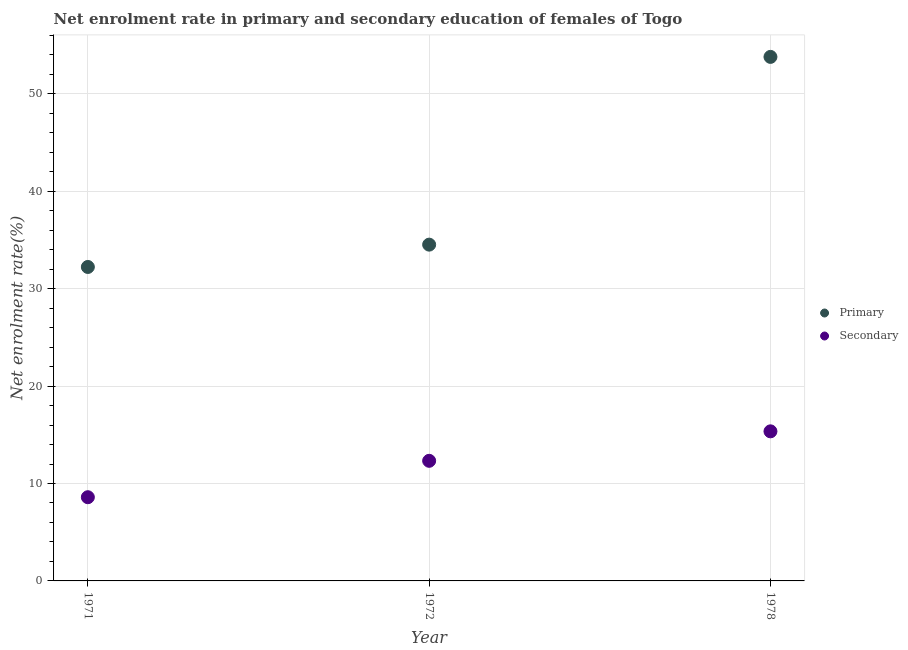Is the number of dotlines equal to the number of legend labels?
Offer a terse response. Yes. What is the enrollment rate in primary education in 1978?
Keep it short and to the point. 53.8. Across all years, what is the maximum enrollment rate in primary education?
Offer a terse response. 53.8. Across all years, what is the minimum enrollment rate in primary education?
Offer a terse response. 32.23. In which year was the enrollment rate in secondary education maximum?
Your response must be concise. 1978. What is the total enrollment rate in primary education in the graph?
Ensure brevity in your answer.  120.55. What is the difference between the enrollment rate in primary education in 1971 and that in 1978?
Keep it short and to the point. -21.57. What is the difference between the enrollment rate in secondary education in 1972 and the enrollment rate in primary education in 1978?
Provide a succinct answer. -41.47. What is the average enrollment rate in secondary education per year?
Your response must be concise. 12.09. In the year 1972, what is the difference between the enrollment rate in secondary education and enrollment rate in primary education?
Ensure brevity in your answer.  -22.19. In how many years, is the enrollment rate in primary education greater than 4 %?
Give a very brief answer. 3. What is the ratio of the enrollment rate in primary education in 1972 to that in 1978?
Your answer should be very brief. 0.64. Is the enrollment rate in secondary education in 1971 less than that in 1972?
Your response must be concise. Yes. Is the difference between the enrollment rate in secondary education in 1972 and 1978 greater than the difference between the enrollment rate in primary education in 1972 and 1978?
Offer a terse response. Yes. What is the difference between the highest and the second highest enrollment rate in primary education?
Offer a very short reply. 19.27. What is the difference between the highest and the lowest enrollment rate in primary education?
Your answer should be compact. 21.57. In how many years, is the enrollment rate in primary education greater than the average enrollment rate in primary education taken over all years?
Ensure brevity in your answer.  1. Does the enrollment rate in primary education monotonically increase over the years?
Your answer should be very brief. Yes. How many dotlines are there?
Offer a terse response. 2. How many years are there in the graph?
Provide a short and direct response. 3. What is the difference between two consecutive major ticks on the Y-axis?
Provide a short and direct response. 10. Are the values on the major ticks of Y-axis written in scientific E-notation?
Make the answer very short. No. Where does the legend appear in the graph?
Your answer should be compact. Center right. What is the title of the graph?
Provide a succinct answer. Net enrolment rate in primary and secondary education of females of Togo. What is the label or title of the Y-axis?
Provide a succinct answer. Net enrolment rate(%). What is the Net enrolment rate(%) of Primary in 1971?
Your answer should be compact. 32.23. What is the Net enrolment rate(%) of Secondary in 1971?
Provide a short and direct response. 8.59. What is the Net enrolment rate(%) of Primary in 1972?
Provide a succinct answer. 34.52. What is the Net enrolment rate(%) in Secondary in 1972?
Offer a terse response. 12.33. What is the Net enrolment rate(%) of Primary in 1978?
Make the answer very short. 53.8. What is the Net enrolment rate(%) in Secondary in 1978?
Provide a short and direct response. 15.36. Across all years, what is the maximum Net enrolment rate(%) of Primary?
Your response must be concise. 53.8. Across all years, what is the maximum Net enrolment rate(%) in Secondary?
Provide a short and direct response. 15.36. Across all years, what is the minimum Net enrolment rate(%) of Primary?
Provide a succinct answer. 32.23. Across all years, what is the minimum Net enrolment rate(%) of Secondary?
Your response must be concise. 8.59. What is the total Net enrolment rate(%) of Primary in the graph?
Offer a very short reply. 120.55. What is the total Net enrolment rate(%) of Secondary in the graph?
Give a very brief answer. 36.28. What is the difference between the Net enrolment rate(%) of Primary in 1971 and that in 1972?
Give a very brief answer. -2.29. What is the difference between the Net enrolment rate(%) of Secondary in 1971 and that in 1972?
Your answer should be very brief. -3.74. What is the difference between the Net enrolment rate(%) of Primary in 1971 and that in 1978?
Make the answer very short. -21.57. What is the difference between the Net enrolment rate(%) of Secondary in 1971 and that in 1978?
Provide a short and direct response. -6.76. What is the difference between the Net enrolment rate(%) of Primary in 1972 and that in 1978?
Your answer should be compact. -19.27. What is the difference between the Net enrolment rate(%) in Secondary in 1972 and that in 1978?
Offer a very short reply. -3.03. What is the difference between the Net enrolment rate(%) of Primary in 1971 and the Net enrolment rate(%) of Secondary in 1972?
Give a very brief answer. 19.9. What is the difference between the Net enrolment rate(%) in Primary in 1971 and the Net enrolment rate(%) in Secondary in 1978?
Give a very brief answer. 16.87. What is the difference between the Net enrolment rate(%) in Primary in 1972 and the Net enrolment rate(%) in Secondary in 1978?
Offer a very short reply. 19.17. What is the average Net enrolment rate(%) of Primary per year?
Your answer should be very brief. 40.18. What is the average Net enrolment rate(%) of Secondary per year?
Your answer should be very brief. 12.09. In the year 1971, what is the difference between the Net enrolment rate(%) of Primary and Net enrolment rate(%) of Secondary?
Your answer should be very brief. 23.64. In the year 1972, what is the difference between the Net enrolment rate(%) in Primary and Net enrolment rate(%) in Secondary?
Offer a very short reply. 22.19. In the year 1978, what is the difference between the Net enrolment rate(%) of Primary and Net enrolment rate(%) of Secondary?
Make the answer very short. 38.44. What is the ratio of the Net enrolment rate(%) of Primary in 1971 to that in 1972?
Make the answer very short. 0.93. What is the ratio of the Net enrolment rate(%) in Secondary in 1971 to that in 1972?
Your answer should be compact. 0.7. What is the ratio of the Net enrolment rate(%) of Primary in 1971 to that in 1978?
Your answer should be compact. 0.6. What is the ratio of the Net enrolment rate(%) of Secondary in 1971 to that in 1978?
Provide a short and direct response. 0.56. What is the ratio of the Net enrolment rate(%) of Primary in 1972 to that in 1978?
Ensure brevity in your answer.  0.64. What is the ratio of the Net enrolment rate(%) in Secondary in 1972 to that in 1978?
Give a very brief answer. 0.8. What is the difference between the highest and the second highest Net enrolment rate(%) of Primary?
Your response must be concise. 19.27. What is the difference between the highest and the second highest Net enrolment rate(%) in Secondary?
Offer a terse response. 3.03. What is the difference between the highest and the lowest Net enrolment rate(%) of Primary?
Ensure brevity in your answer.  21.57. What is the difference between the highest and the lowest Net enrolment rate(%) of Secondary?
Provide a succinct answer. 6.76. 